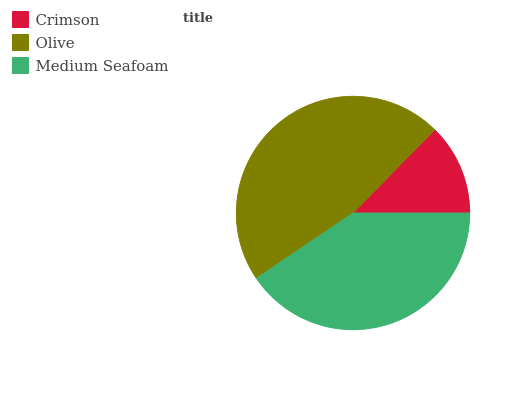Is Crimson the minimum?
Answer yes or no. Yes. Is Olive the maximum?
Answer yes or no. Yes. Is Medium Seafoam the minimum?
Answer yes or no. No. Is Medium Seafoam the maximum?
Answer yes or no. No. Is Olive greater than Medium Seafoam?
Answer yes or no. Yes. Is Medium Seafoam less than Olive?
Answer yes or no. Yes. Is Medium Seafoam greater than Olive?
Answer yes or no. No. Is Olive less than Medium Seafoam?
Answer yes or no. No. Is Medium Seafoam the high median?
Answer yes or no. Yes. Is Medium Seafoam the low median?
Answer yes or no. Yes. Is Olive the high median?
Answer yes or no. No. Is Crimson the low median?
Answer yes or no. No. 